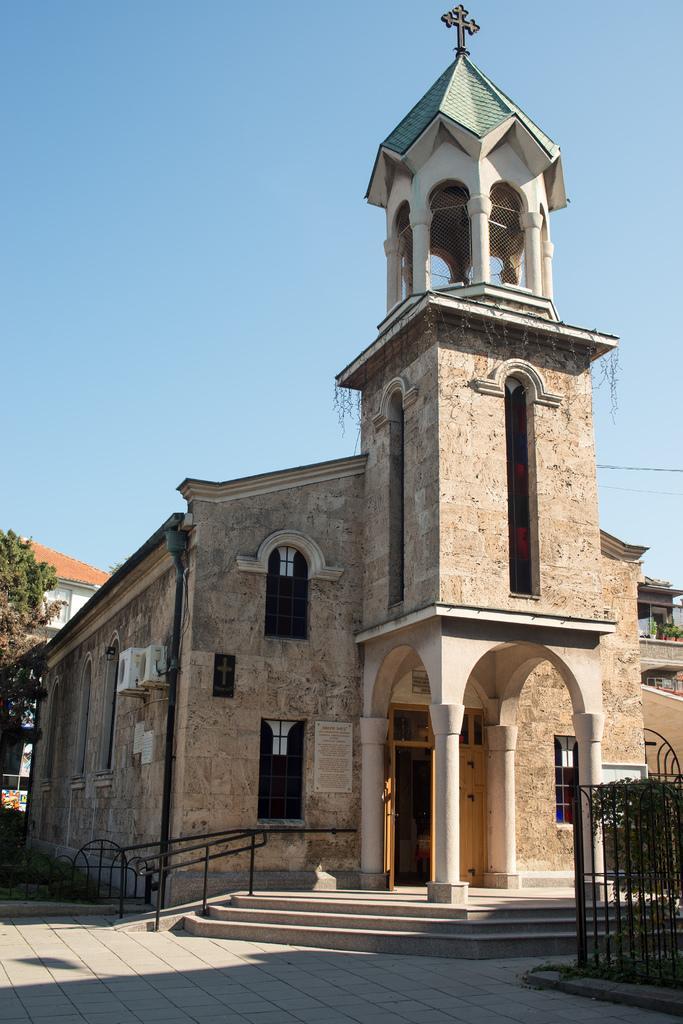Please provide a concise description of this image. In this picture we can see the buildings, windows, mesh, pillars, door. On the left side of the image we can see a tree, roof, air conditioners, pole, light. On the right side of the image we can see the pots, plants, balcony. At the bottom of the image we can see the stairs, floor, grilles. At the top of the image we can see the sky. 